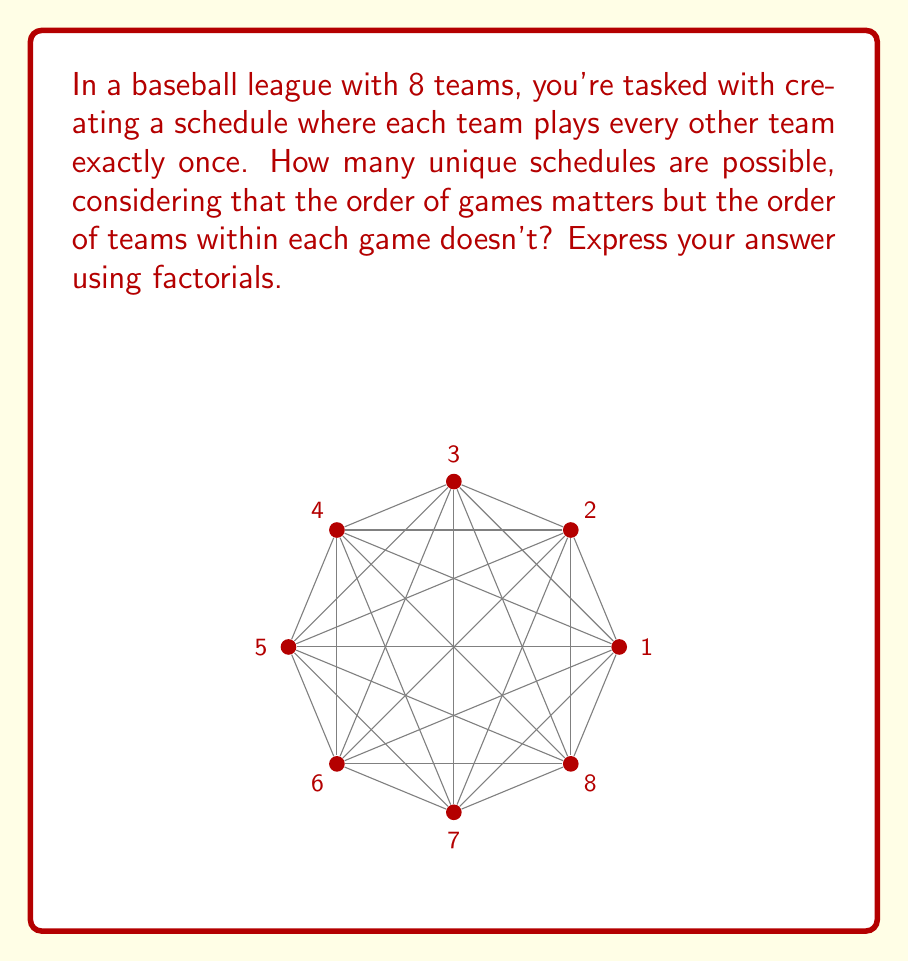Show me your answer to this math problem. Let's approach this step-by-step:

1) First, we need to determine the total number of games. With 8 teams, each team plays 7 others. The total number of games is:

   $\frac{8 \times 7}{2} = 28$ games

2) Now, we need to arrange these 28 games in order. This is a permutation of 28 items, which is typically represented as 28!

3) However, we're overcounting. For each game, the order of the two teams doesn't matter. For example, Team 1 vs Team 2 is the same as Team 2 vs Team 1.

4) For each game, there are 2! ways to arrange the teams, and we have 28 games. So we need to divide our total by $(2!)^{28}$

5) Therefore, the number of unique schedules is:

   $$\frac{28!}{(2!)^{28}}$$

6) This can be simplified to:

   $$\frac{28!}{2^{28}}$$

This formula accounts for all possible orderings of the games (28!) while eliminating the redundancies caused by the irrelevance of team order within each game (dividing by $2^{28}$).
Answer: $\frac{28!}{2^{28}}$ 